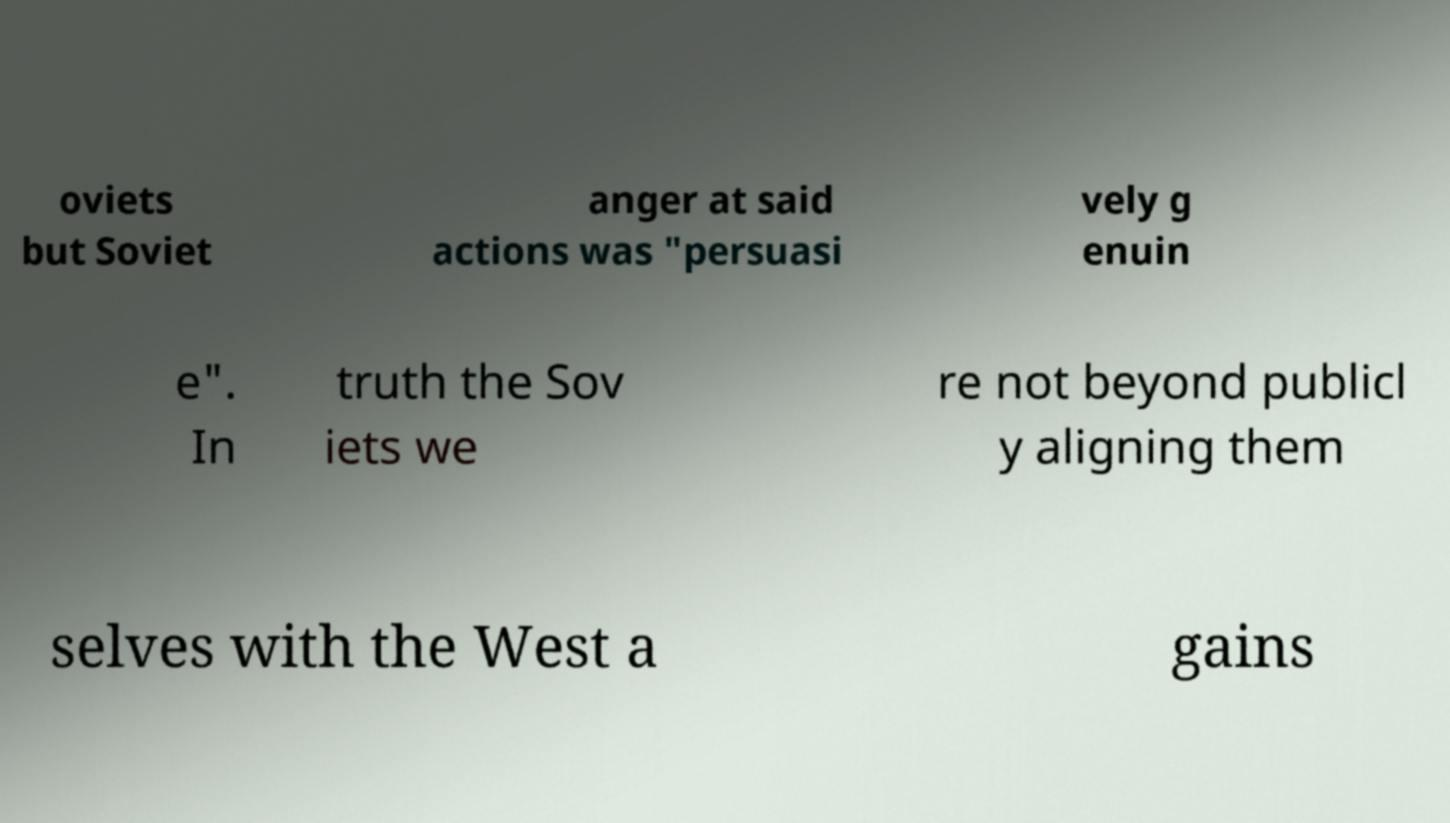There's text embedded in this image that I need extracted. Can you transcribe it verbatim? oviets but Soviet anger at said actions was "persuasi vely g enuin e". In truth the Sov iets we re not beyond publicl y aligning them selves with the West a gains 